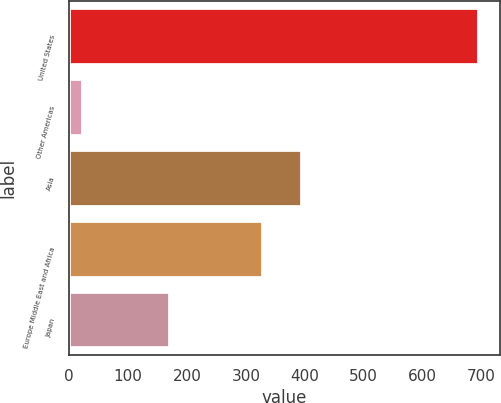Convert chart to OTSL. <chart><loc_0><loc_0><loc_500><loc_500><bar_chart><fcel>United States<fcel>Other Americas<fcel>Asia<fcel>Europe Middle East and Africa<fcel>Japan<nl><fcel>696.6<fcel>23.4<fcel>396.02<fcel>328.7<fcel>172<nl></chart> 